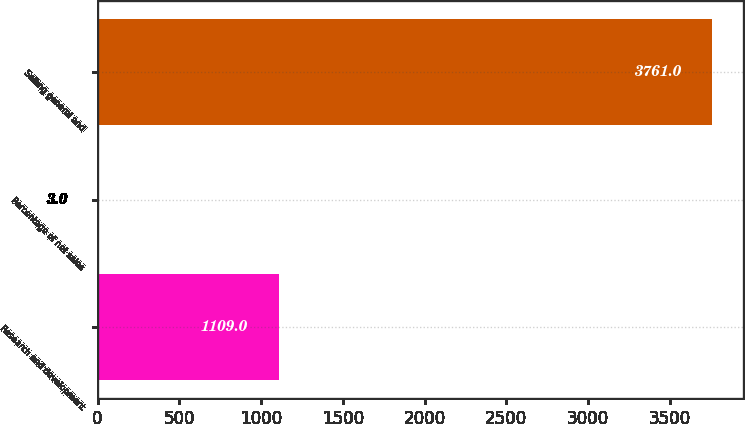Convert chart. <chart><loc_0><loc_0><loc_500><loc_500><bar_chart><fcel>Research and development<fcel>Percentage of net sales<fcel>Selling general and<nl><fcel>1109<fcel>3<fcel>3761<nl></chart> 